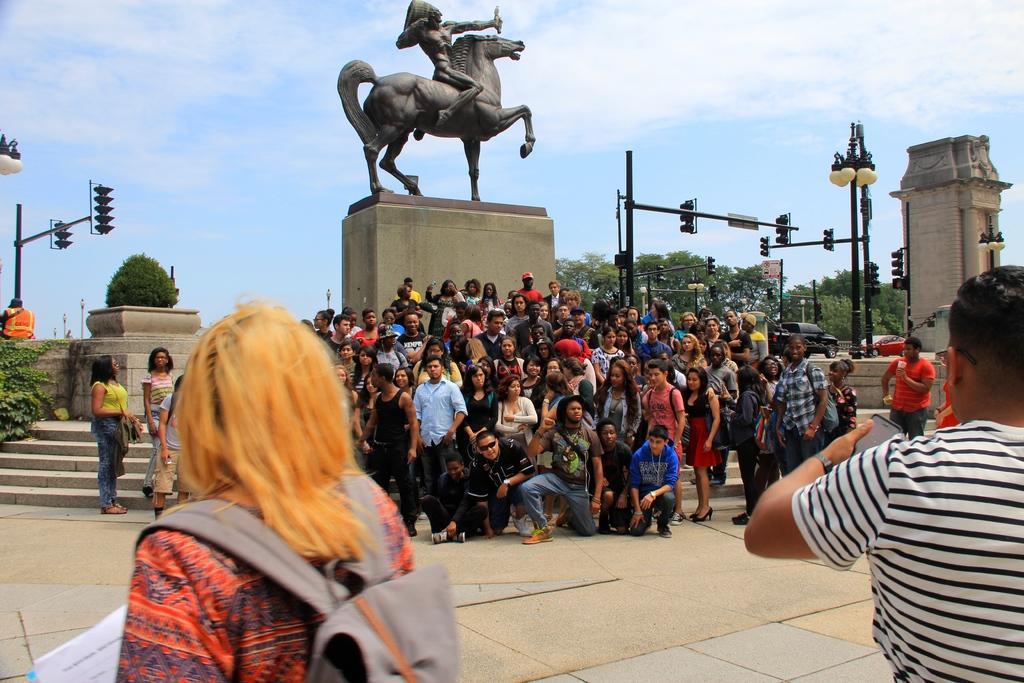In one or two sentences, can you explain what this image depicts? In the foreground, I can see a crowd on the road and on the steps. In the background, I can see a statue, light poles, pillars, trees, plants and the sky. This image is taken, maybe in a day. 